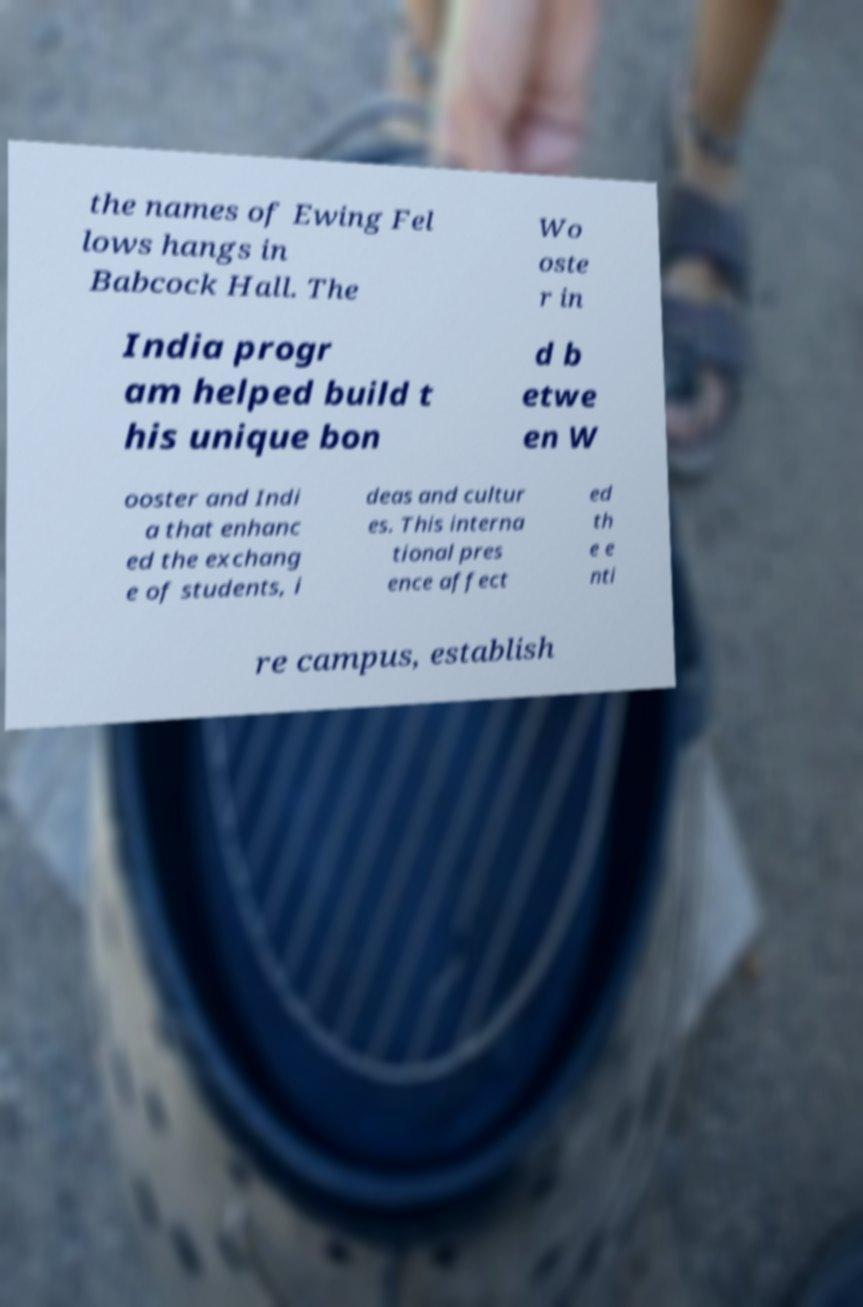Can you accurately transcribe the text from the provided image for me? the names of Ewing Fel lows hangs in Babcock Hall. The Wo oste r in India progr am helped build t his unique bon d b etwe en W ooster and Indi a that enhanc ed the exchang e of students, i deas and cultur es. This interna tional pres ence affect ed th e e nti re campus, establish 